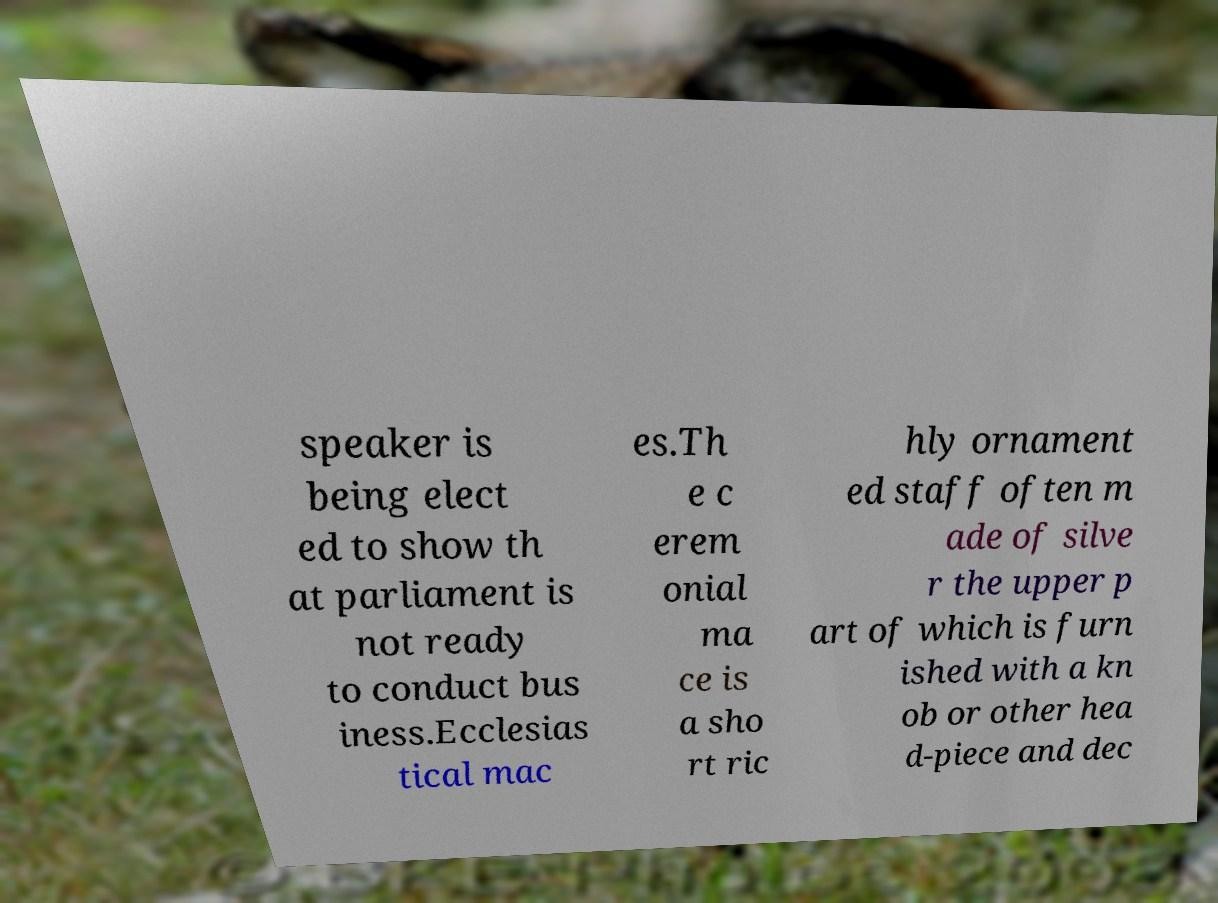There's text embedded in this image that I need extracted. Can you transcribe it verbatim? speaker is being elect ed to show th at parliament is not ready to conduct bus iness.Ecclesias tical mac es.Th e c erem onial ma ce is a sho rt ric hly ornament ed staff often m ade of silve r the upper p art of which is furn ished with a kn ob or other hea d-piece and dec 